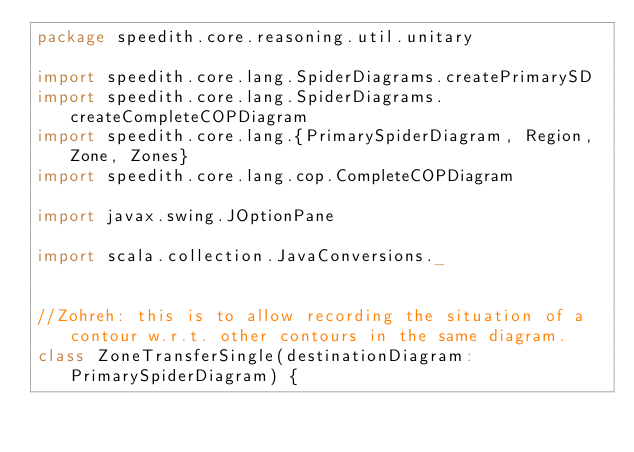Convert code to text. <code><loc_0><loc_0><loc_500><loc_500><_Scala_>package speedith.core.reasoning.util.unitary

import speedith.core.lang.SpiderDiagrams.createPrimarySD
import speedith.core.lang.SpiderDiagrams.createCompleteCOPDiagram
import speedith.core.lang.{PrimarySpiderDiagram, Region, Zone, Zones}
import speedith.core.lang.cop.CompleteCOPDiagram

import javax.swing.JOptionPane

import scala.collection.JavaConversions._


//Zohreh: this is to allow recording the situation of a contour w.r.t. other contours in the same diagram.
class ZoneTransferSingle(destinationDiagram: PrimarySpiderDiagram) {
</code> 